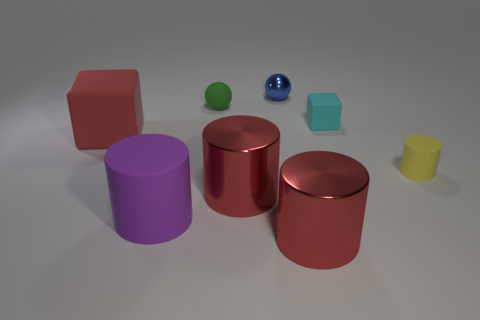Is there a pattern in the arrangement of these objects? There doesn't appear to be a deliberate pattern to the arrangement of these objects. They seem randomly placed with varying distances between them, but the layout can evoke a sense of balance and color diversity. 